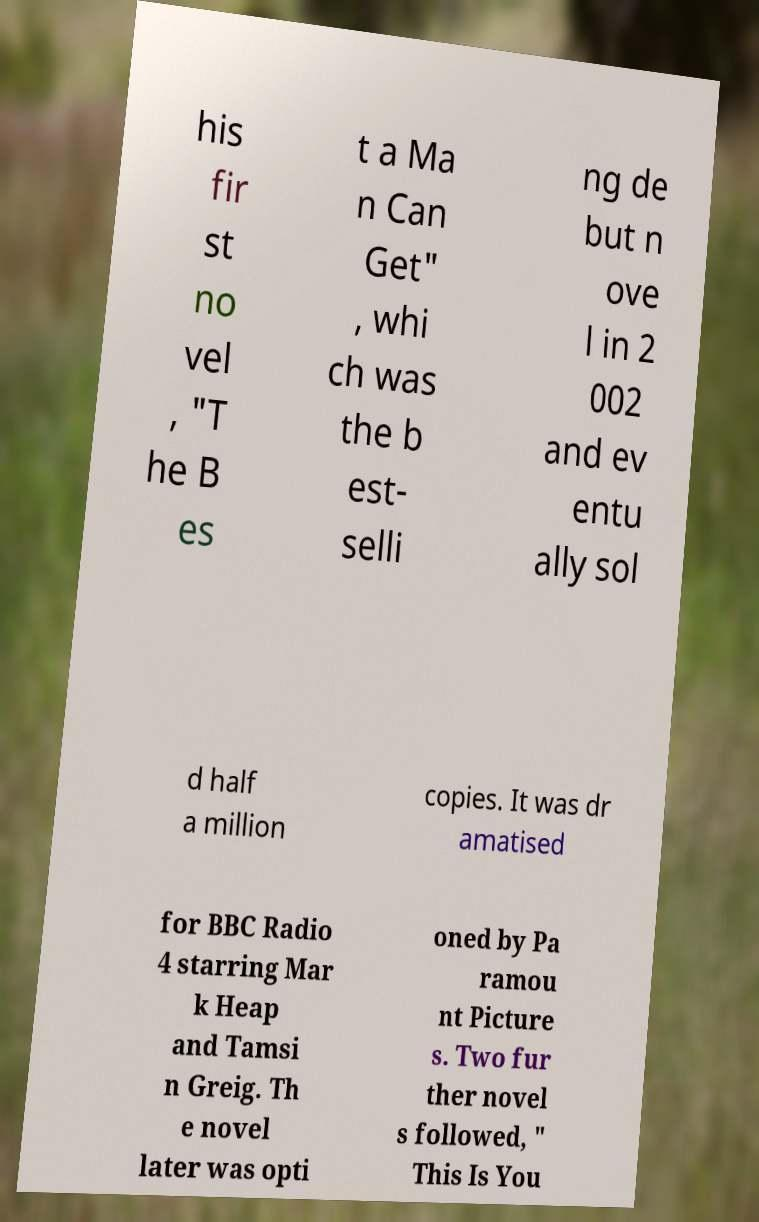Could you extract and type out the text from this image? his fir st no vel , "T he B es t a Ma n Can Get" , whi ch was the b est- selli ng de but n ove l in 2 002 and ev entu ally sol d half a million copies. It was dr amatised for BBC Radio 4 starring Mar k Heap and Tamsi n Greig. Th e novel later was opti oned by Pa ramou nt Picture s. Two fur ther novel s followed, " This Is You 